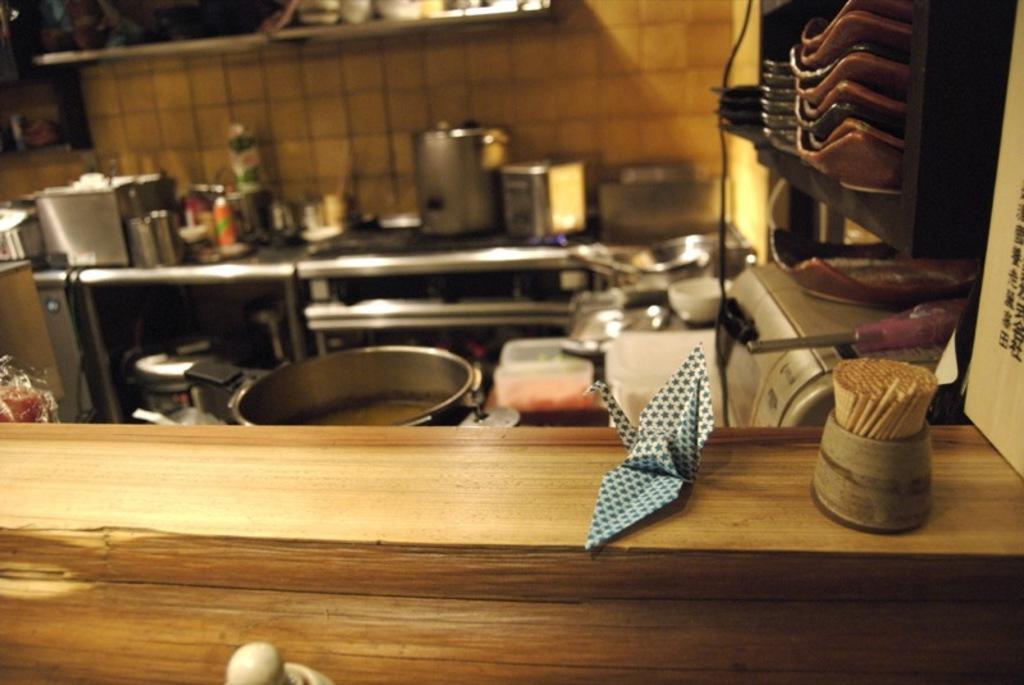Please provide a concise description of this image. This image is clicked inside kitchen,in the front there are tooth pricks on a table along with a paper and behind there are many utensils,bowls,jars,pans on the table in front of wall, on the right side there are plates in a rack. 